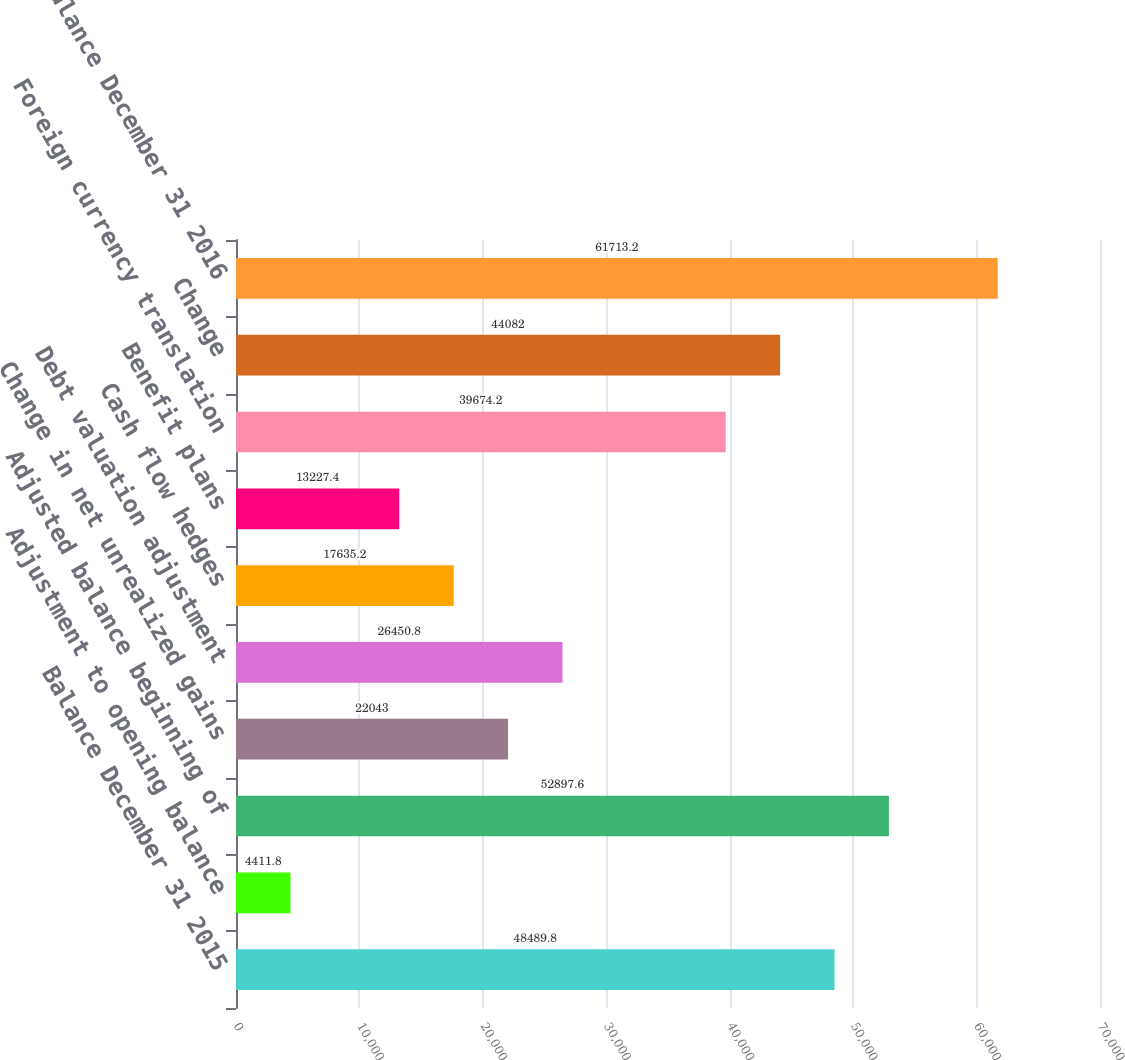Convert chart. <chart><loc_0><loc_0><loc_500><loc_500><bar_chart><fcel>Balance December 31 2015<fcel>Adjustment to opening balance<fcel>Adjusted balance beginning of<fcel>Change in net unrealized gains<fcel>Debt valuation adjustment<fcel>Cash flow hedges<fcel>Benefit plans<fcel>Foreign currency translation<fcel>Change<fcel>Balance December 31 2016<nl><fcel>48489.8<fcel>4411.8<fcel>52897.6<fcel>22043<fcel>26450.8<fcel>17635.2<fcel>13227.4<fcel>39674.2<fcel>44082<fcel>61713.2<nl></chart> 